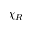Convert formula to latex. <formula><loc_0><loc_0><loc_500><loc_500>\chi _ { R }</formula> 